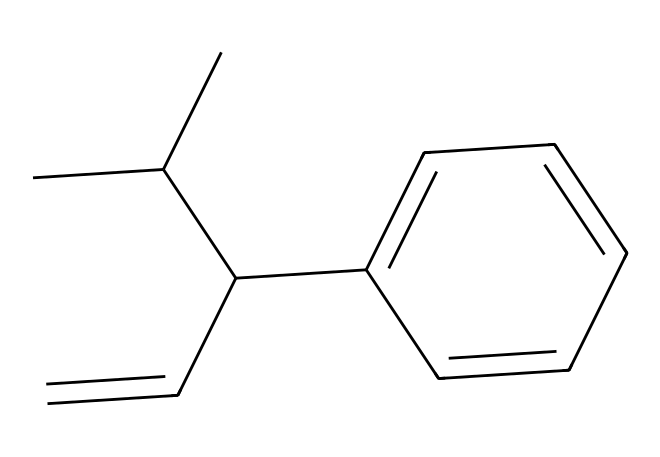How many carbon atoms are in this molecule? By analyzing the SMILES representation, we can count the number of carbon (C) symbols present. Each "C" indicates a carbon atom. In the provided SMILES, there are ten carbon atoms.
Answer: ten What is the type of this chemical compound? The structure indicates that it is an organic compound due to the presence of multiple carbon atoms and typical carbon-based functional groups. This specific compound is a type of synthetic rubber.
Answer: synthetic rubber How many double bonds are present in this molecule? When examining the SMILES, we can identify double bonds by looking for the "=" sign. In this case, there is one double bond found between the carbon atoms in the structure.
Answer: one Which functional group is characteristic of unsaturation in this compound? The presence of a double bond indicates unsaturation in organic molecules. In this case, the double bond represents a vinyl or alkene functional group.
Answer: alkene Is this compound soluble in water? This compound, being a non-electrolyte and primarily composed of hydrocarbons with no polar functional groups, suggests it has low solubility in water.
Answer: low What type of intermolecular forces are primarily at play in this non-electrolyte? Non-electrolytes like this compound primarily exhibit dispersion forces due to the hydrocarbon character and the absence of strong dipoles or ionic interactions.
Answer: dispersion forces 